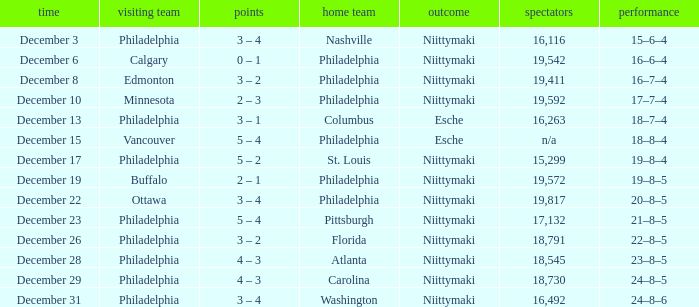What was the decision when the attendance was 19,592? Niittymaki. 